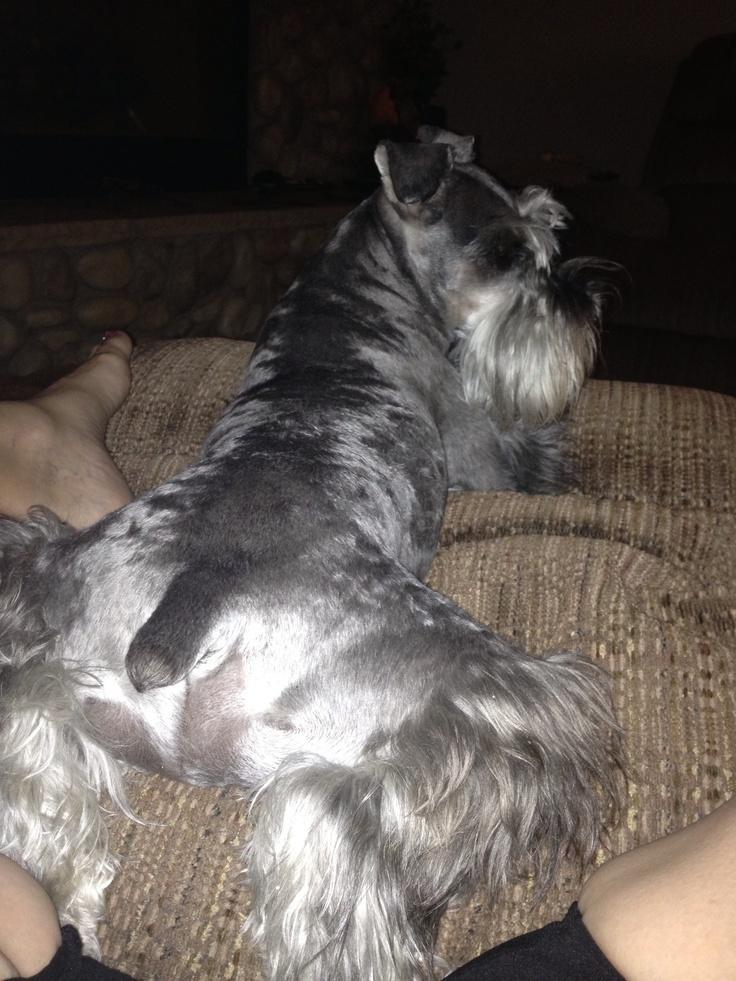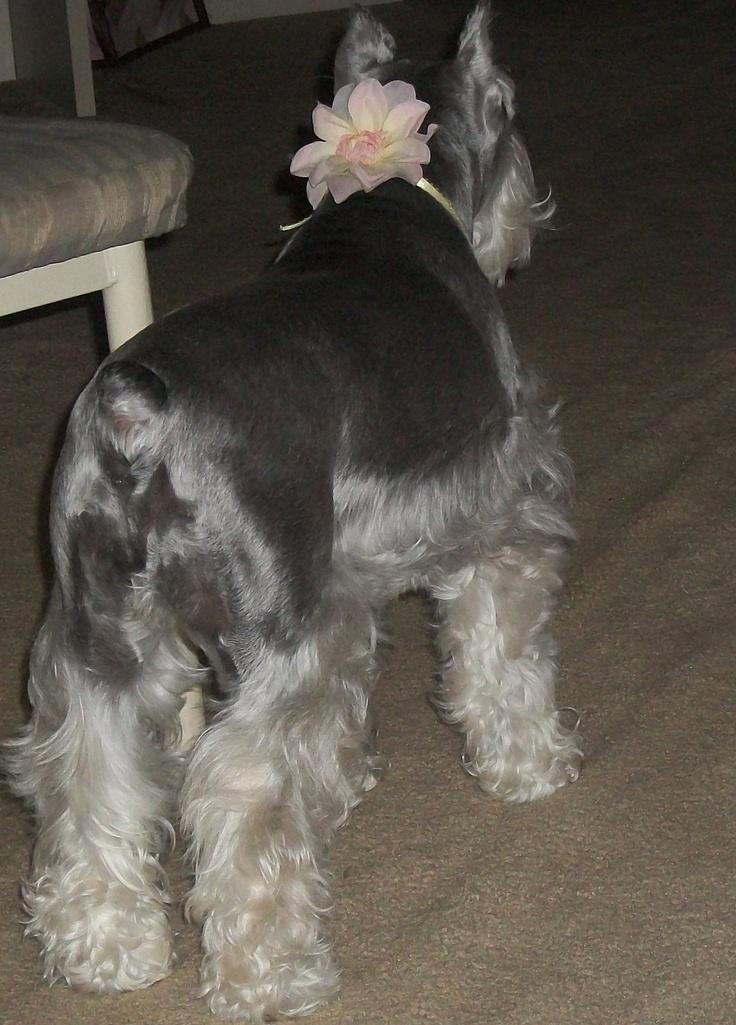The first image is the image on the left, the second image is the image on the right. Analyze the images presented: Is the assertion "The left image shows a schnauzer with its rear to the camera, lying on its belly on a pillow, with its legs extended behind it and its head turned to the right." valid? Answer yes or no. Yes. The first image is the image on the left, the second image is the image on the right. Examine the images to the left and right. Is the description "All the dogs are laying on their stomachs." accurate? Answer yes or no. No. 